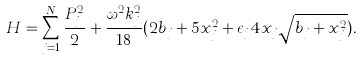<formula> <loc_0><loc_0><loc_500><loc_500>H = \sum _ { j = 1 } ^ { N } \frac { P _ { j } ^ { 2 } } { 2 } + \frac { \omega ^ { 2 } k _ { j } ^ { 2 } } { 1 8 } ( 2 b _ { j } + 5 x _ { j } ^ { 2 } + \epsilon _ { j } 4 x _ { j } \sqrt { b _ { j } + x _ { j } ^ { 2 } } ) .</formula> 